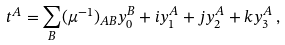<formula> <loc_0><loc_0><loc_500><loc_500>t ^ { A } = \sum _ { B } ( \mu ^ { - 1 } ) _ { A B } y ^ { B } _ { 0 } + i y ^ { A } _ { 1 } + j y ^ { A } _ { 2 } + k y ^ { A } _ { 3 } \, ,</formula> 